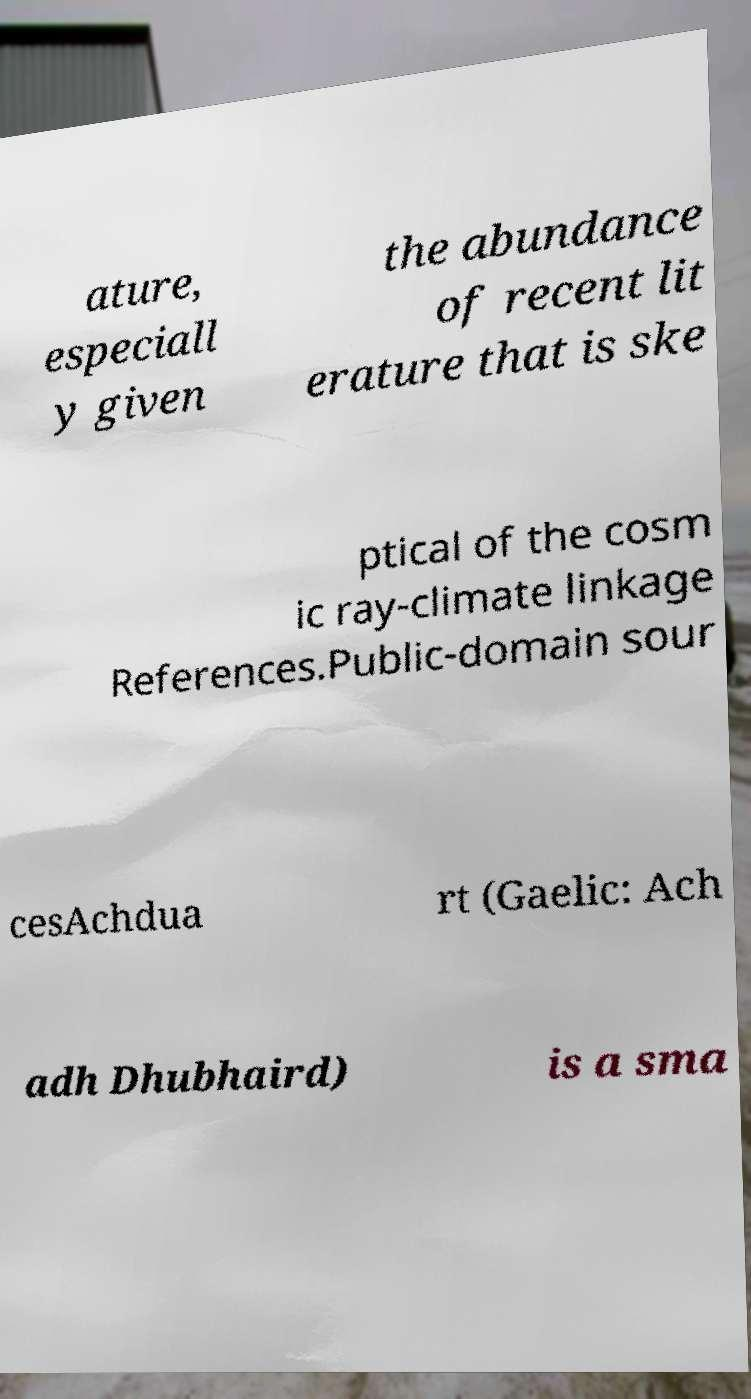Could you assist in decoding the text presented in this image and type it out clearly? ature, especiall y given the abundance of recent lit erature that is ske ptical of the cosm ic ray-climate linkage References.Public-domain sour cesAchdua rt (Gaelic: Ach adh Dhubhaird) is a sma 